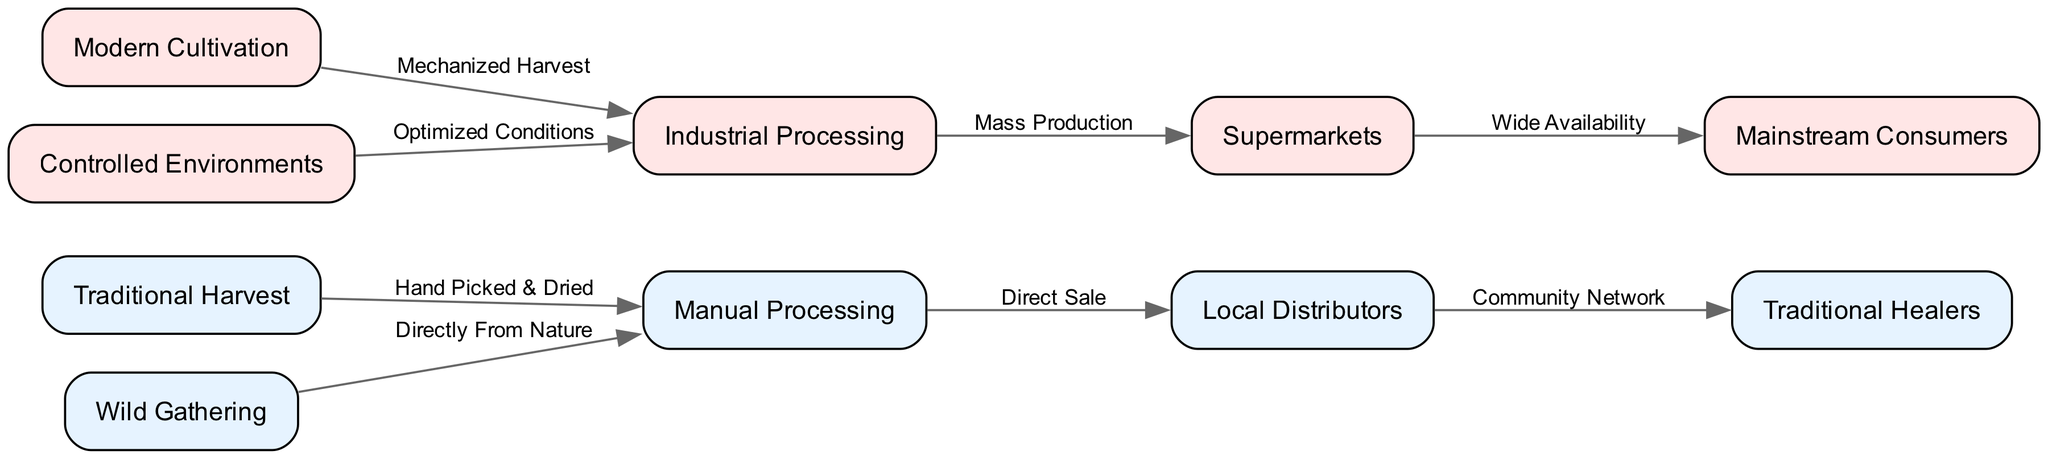What are the two main methods of herb harvesting shown in the diagram? The diagram shows "Traditional Harvest" and "Modern Cultivation" as the two main methods of herb harvesting.
Answer: Traditional Harvest, Modern Cultivation How many nodes are in the diagram? Counting the different labeled elements, there are ten nodes representing various processes and entities in the herb procurement chain.
Answer: 10 What type of processing method is used for traditional harvest herbs? The diagram indicates that traditional herbs are processed through "Manual Processing" after they are harvested.
Answer: Manual Processing Which method leads directly to supermarkets? "Industrial Processing" is the method that leads directly to supermarkets as noted in the flow of the diagram.
Answer: Industrial Processing How do local distributors connect to traditional healers? The connection is established through a "Community Network," indicating how local distributors support traditional healers in the procurement process.
Answer: Community Network Which herb procurement method involves optimized conditions for growth? "Controlled Environments" is specified in the diagram as the method that utilizes optimized conditions for herbal growth and cultivation.
Answer: Controlled Environments What processing method follows wild gathering? According to the diagram, herbs obtained through "Wild Gathering" go directly to "Manual Processing" without any intervening steps.
Answer: Manual Processing How many distinct edges connect the nodes in the diagram? By counting the lines connecting the nodes, there are eight distinct edges denoting the relationships between different methods and processes.
Answer: 8 What is the final target consumer of herbs in this diagram? The "Mainstream Consumers" are identified as the final target consumers of herbs shown in the diagram's flow.
Answer: Mainstream Consumers What type of harvesting method involves hand-picking and drying? "Traditional Harvest" involves the practice of hand-picking and drying herbs as indicated in the diagram's flow.
Answer: Traditional Harvest 